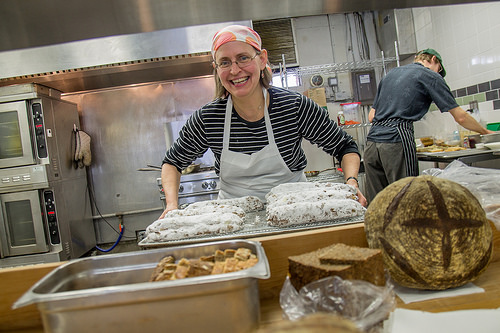<image>
Can you confirm if the woman is behind the bread? Yes. From this viewpoint, the woman is positioned behind the bread, with the bread partially or fully occluding the woman. Where is the women in relation to the food? Is it in front of the food? No. The women is not in front of the food. The spatial positioning shows a different relationship between these objects. 